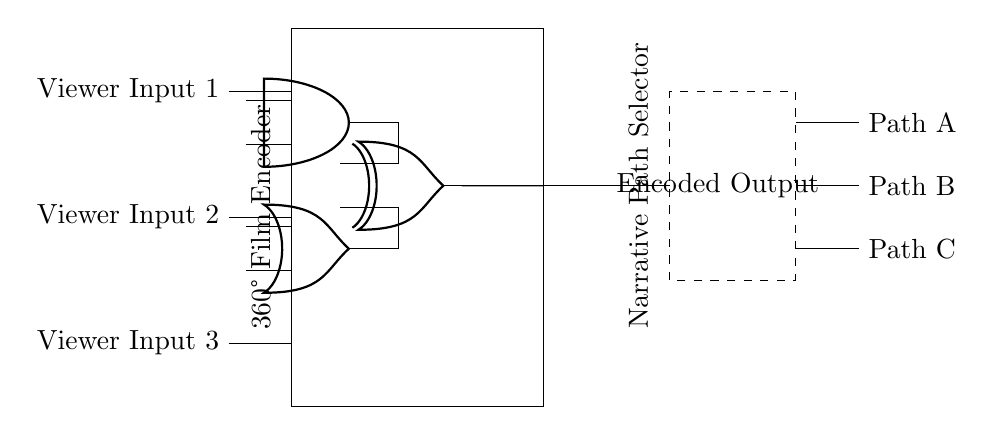What type of logic gates are present in this circuit? The circuit contains an AND gate, an OR gate, and an XOR gate. These are standard logic gate types used for processing binary inputs.
Answer: AND, OR, XOR How many viewer inputs are processed by the encoder? The circuit shows three viewer inputs connected to the encoder, indicating that it is designed to handle multiple inputs simultaneously.
Answer: Three What is the function of the encoder in this circuit? The encoder takes multiple viewer inputs and processes them using the logic gates to produce a single encoded output. Its role is to convert the viewer's choices into a format suitable for narrative selection.
Answer: Encoding viewer inputs What is the output of the logic gates connected to the encoder? The output is from the XOR gate, which takes inputs from the AND and OR gates, indicating that the encoded output is a combination of the processed signals from multiple viewer inputs.
Answer: Encoded Output Which component selects the narrative path? The dashed rectangle labeled "Narrative Path Selector" indicates the component responsible for directing the flow based on the encoded output from the encoder. This indicates the selection of the narrative path based on processed viewer input.
Answer: Narrative Path Selector What paths can the viewer choose from after the encoder? The viewer can choose from Path A, Path B, and Path C as indicated by the branches extending from the narrative path selector, which are the possible narrative routes based on the processed input.
Answer: Path A, Path B, Path C How are the AND and OR gates connected in this circuit? The AND gate receives inputs from Viewer Input 1 and Viewer Input 2, while the OR gate connects to Viewer Input 2 and Viewer Input 3. This means both gates are processing different combinations of the viewer inputs to produce outputs for the XOR gate.
Answer: Simultaneously processing viewer inputs 